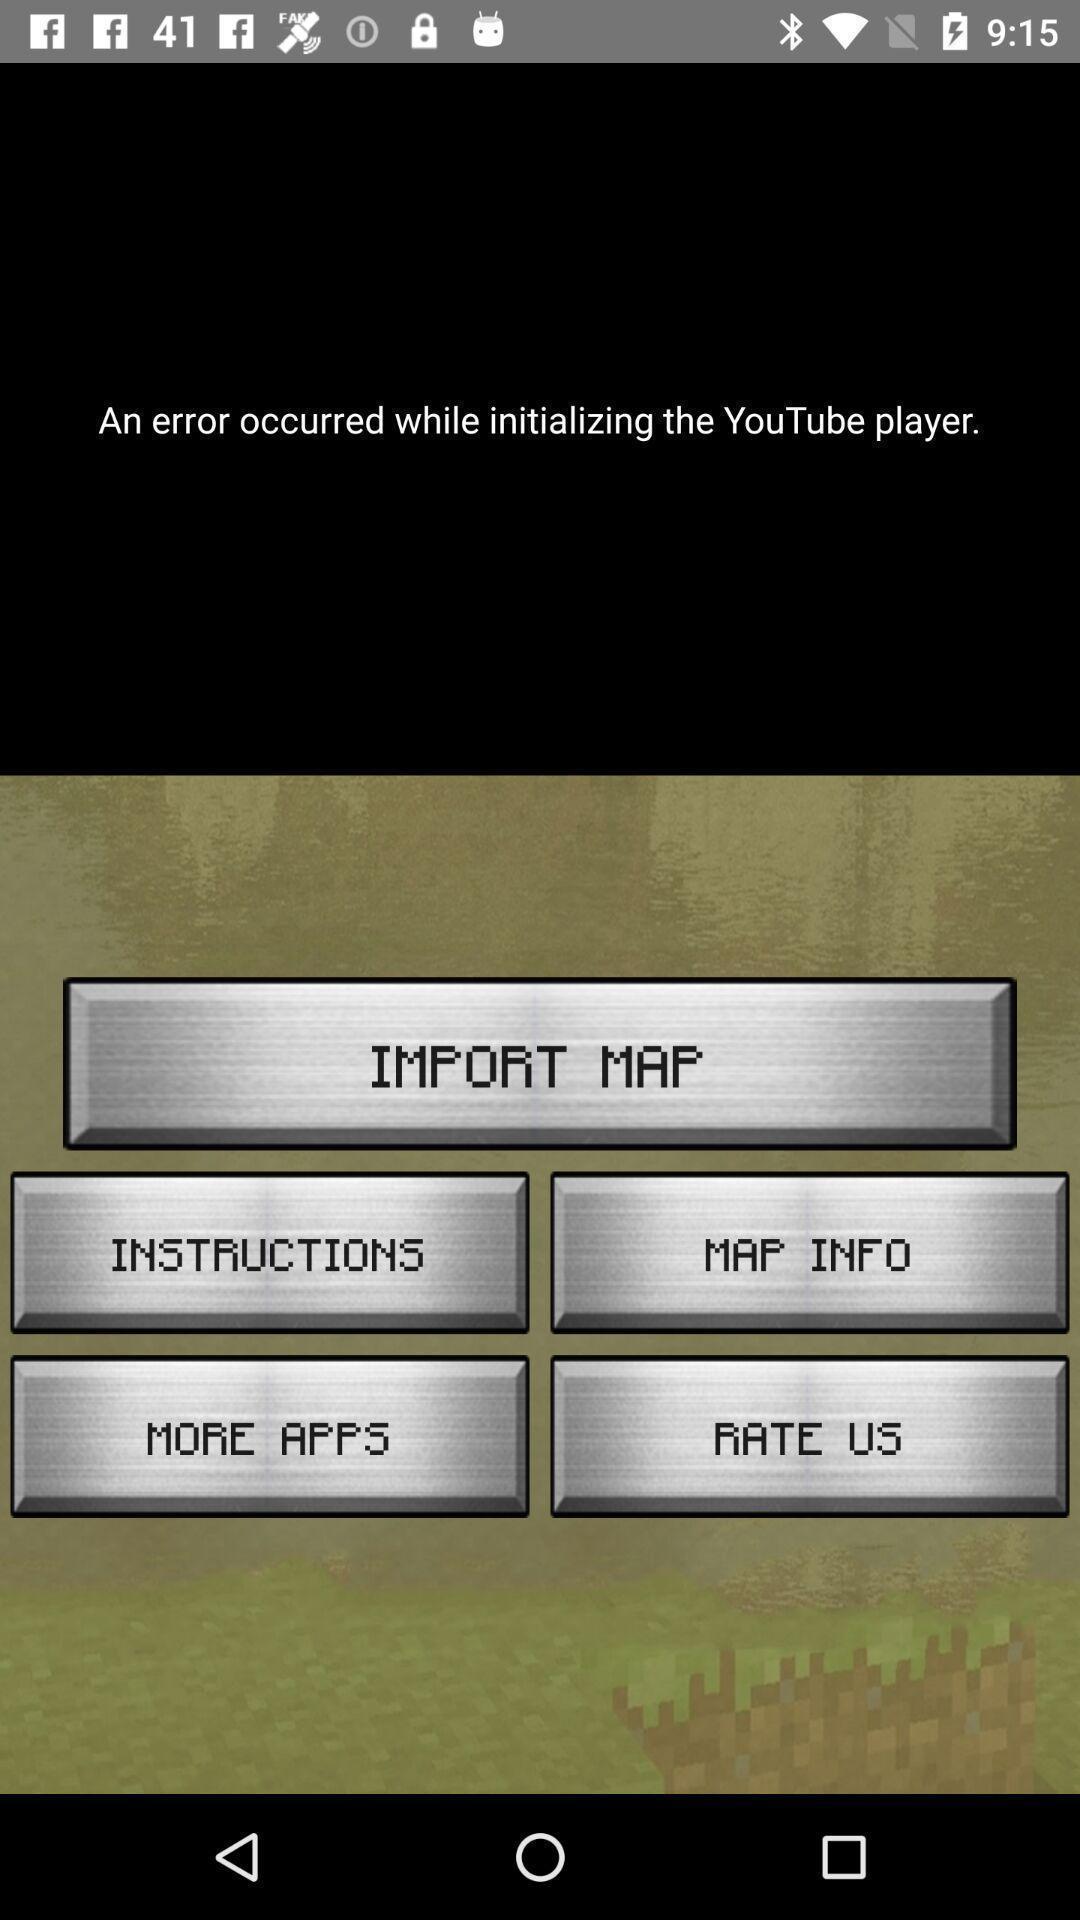Provide a description of this screenshot. Screen showing an error occurred while initializing a application. 